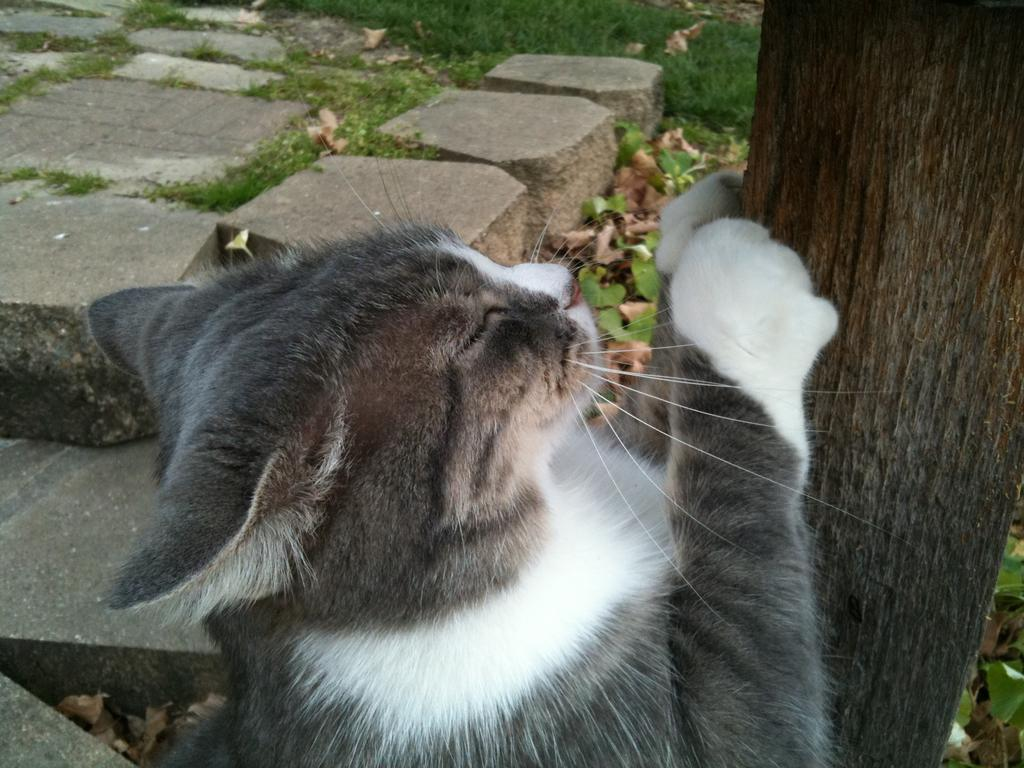What type of animal is in the image? There is a black color cat in the image. What is the background of the image? There is grass in the image. Can you describe any other elements in the image? There is a tree stem in the image. What type of clam is visible in the image? There is no clam present in the image; it features a black color cat, grass, and a tree stem. 